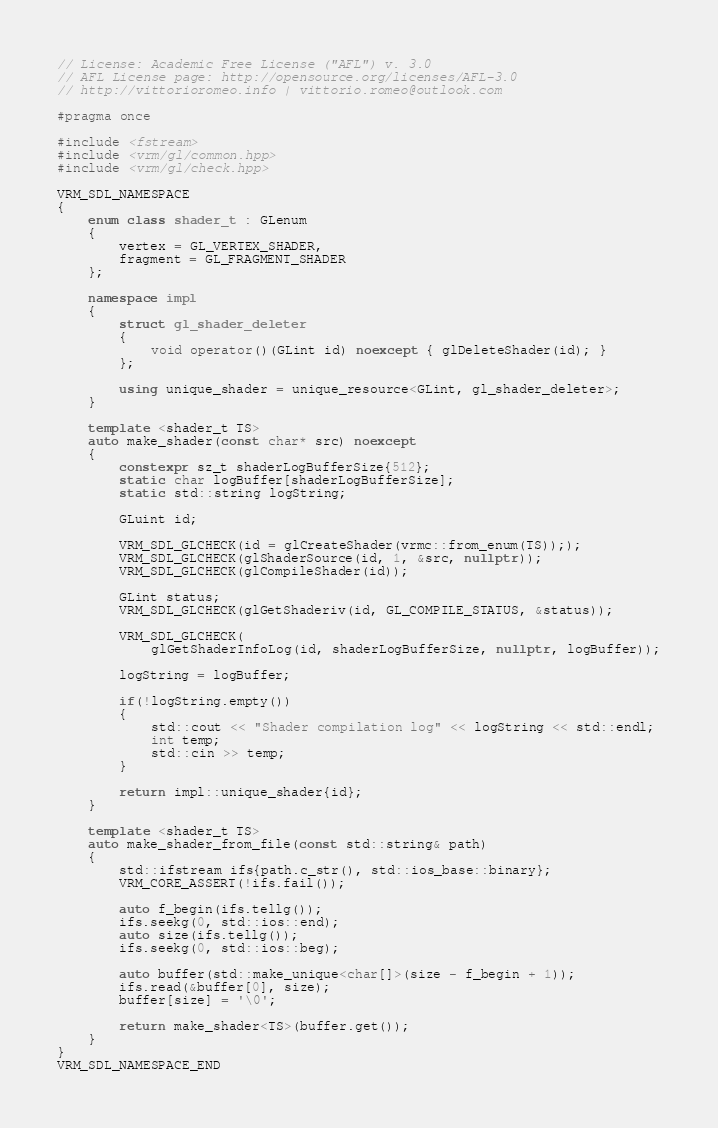<code> <loc_0><loc_0><loc_500><loc_500><_C++_>// License: Academic Free License ("AFL") v. 3.0
// AFL License page: http://opensource.org/licenses/AFL-3.0
// http://vittorioromeo.info | vittorio.romeo@outlook.com

#pragma once

#include <fstream>
#include <vrm/gl/common.hpp>
#include <vrm/gl/check.hpp>

VRM_SDL_NAMESPACE
{
    enum class shader_t : GLenum
    {
        vertex = GL_VERTEX_SHADER,
        fragment = GL_FRAGMENT_SHADER
    };

    namespace impl
    {
        struct gl_shader_deleter
        {
            void operator()(GLint id) noexcept { glDeleteShader(id); }
        };

        using unique_shader = unique_resource<GLint, gl_shader_deleter>;
    }

    template <shader_t TS>
    auto make_shader(const char* src) noexcept
    {
        constexpr sz_t shaderLogBufferSize{512};
        static char logBuffer[shaderLogBufferSize];
        static std::string logString;

        GLuint id;

        VRM_SDL_GLCHECK(id = glCreateShader(vrmc::from_enum(TS)););
        VRM_SDL_GLCHECK(glShaderSource(id, 1, &src, nullptr));
        VRM_SDL_GLCHECK(glCompileShader(id));

        GLint status;
        VRM_SDL_GLCHECK(glGetShaderiv(id, GL_COMPILE_STATUS, &status));

        VRM_SDL_GLCHECK(
            glGetShaderInfoLog(id, shaderLogBufferSize, nullptr, logBuffer));

        logString = logBuffer;

        if(!logString.empty())
        {
            std::cout << "Shader compilation log" << logString << std::endl;
            int temp;
            std::cin >> temp;
        }

        return impl::unique_shader{id};
    }

    template <shader_t TS>
    auto make_shader_from_file(const std::string& path)
    {
        std::ifstream ifs{path.c_str(), std::ios_base::binary};
        VRM_CORE_ASSERT(!ifs.fail());

        auto f_begin(ifs.tellg());
        ifs.seekg(0, std::ios::end);
        auto size(ifs.tellg());
        ifs.seekg(0, std::ios::beg);

        auto buffer(std::make_unique<char[]>(size - f_begin + 1));
        ifs.read(&buffer[0], size);
        buffer[size] = '\0';

        return make_shader<TS>(buffer.get());
    }
}
VRM_SDL_NAMESPACE_END</code> 